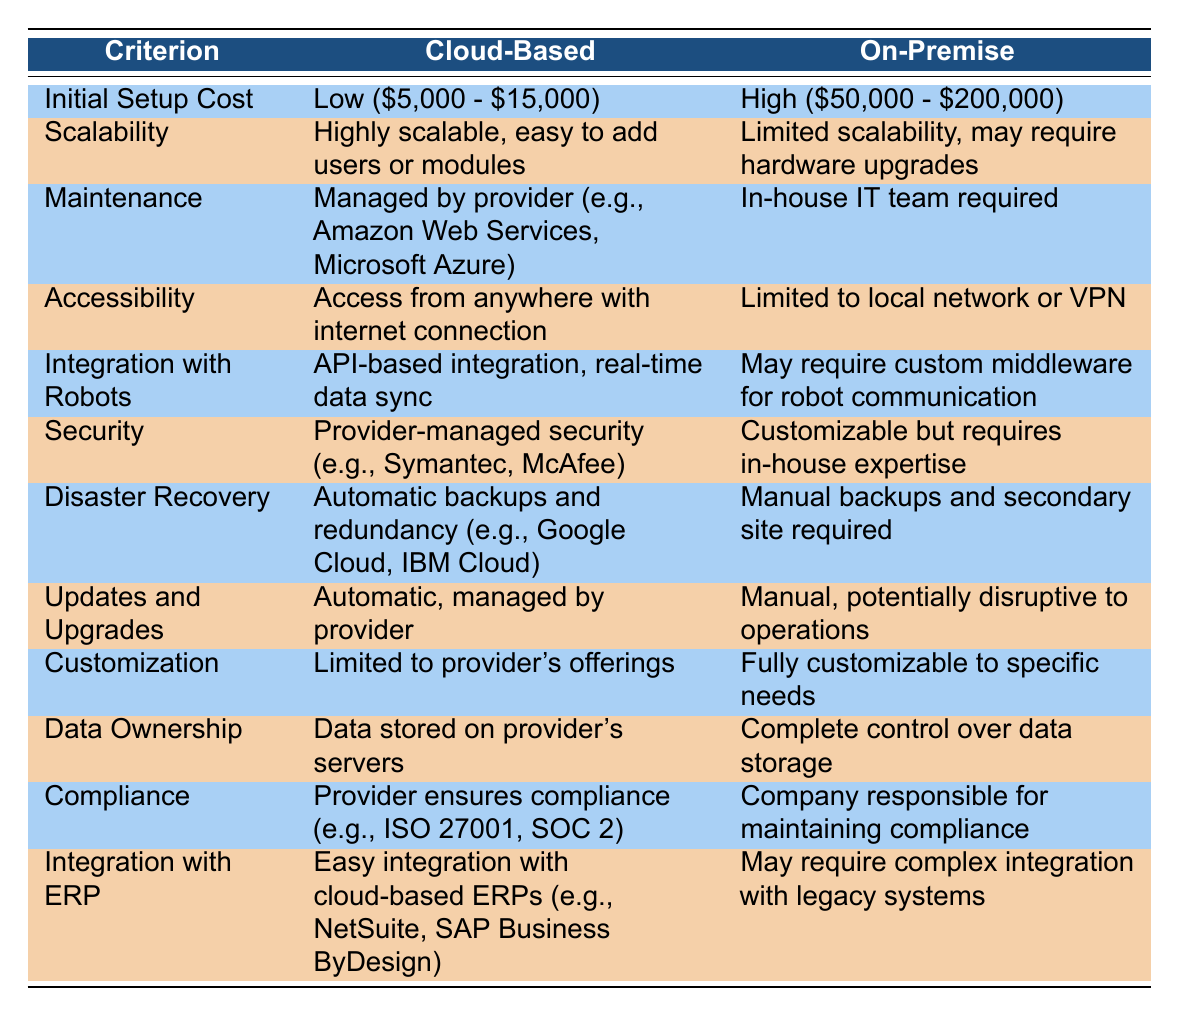What is the initial setup cost for a cloud-based inventory management system? According to the table, the initial setup cost for a cloud-based inventory management system is stated as Low ($5,000 - $15,000).
Answer: Low ($5,000 - $15,000) Is the accessibility to an on-premise system limited to a local network? The table specifies that access to an on-premise system is Limited to local network or VPN, indicating it does not have broad accessibility compared to a cloud-based system.
Answer: Yes Which system offers automatic updates, and who manages them? The table indicates that cloud-based systems offer Automatic, managed by provider updates, while on-premise systems require Manual, potentially disruptive to operations updates.
Answer: Cloud-based; managed by provider How do the scalability options compare between cloud-based and on-premise systems? The table suggests that cloud-based systems are Highly scalable, easy to add users or modules, while on-premise systems have Limited scalability and may require hardware upgrades, indicating a significant difference in flexibility.
Answer: Cloud-based is more scalable If a company wants complete control over data storage, which system should they choose? The table notes that on-premise systems provide Complete control over data storage, while cloud-based systems store data on the provider's servers. Therefore, for complete control over data, an on-premise system is preferable.
Answer: On-premise system What does the table indicate about disaster recovery for cloud-based inventory management systems? The table shows that disaster recovery for cloud-based systems includes Automatic backups and redundancy, while on-premise systems require Manual backups and secondary site, highlighting the ease and reliability of cloud solutions in disaster scenarios.
Answer: Automatic backups and redundancy Is it possible to customize a cloud-based inventory management system to specific needs? The table states that Customization for cloud-based systems is Limited to provider's offerings, while on-premise systems are Fully customizable to specific needs. Therefore, customization is not possible to the same extent in cloud-based systems.
Answer: No What is the compliance responsibility for cloud-based systems? According to the data, the provider ensures compliance for cloud-based systems, while companies are responsible for maintaining compliance for on-premise systems. This highlights a significant distinction in compliance management between the two options.
Answer: Provider ensures compliance How would you summarize the differences in security management between the two systems? The table indicates that cloud-based systems have Provider-managed security, while on-premise systems are Customizable but require in-house expertise. This reflects that cloud solutions offer a more straightforward security approach at the cost of customization.
Answer: Cloud-based is provider-managed; on-premise requires in-house expertise 